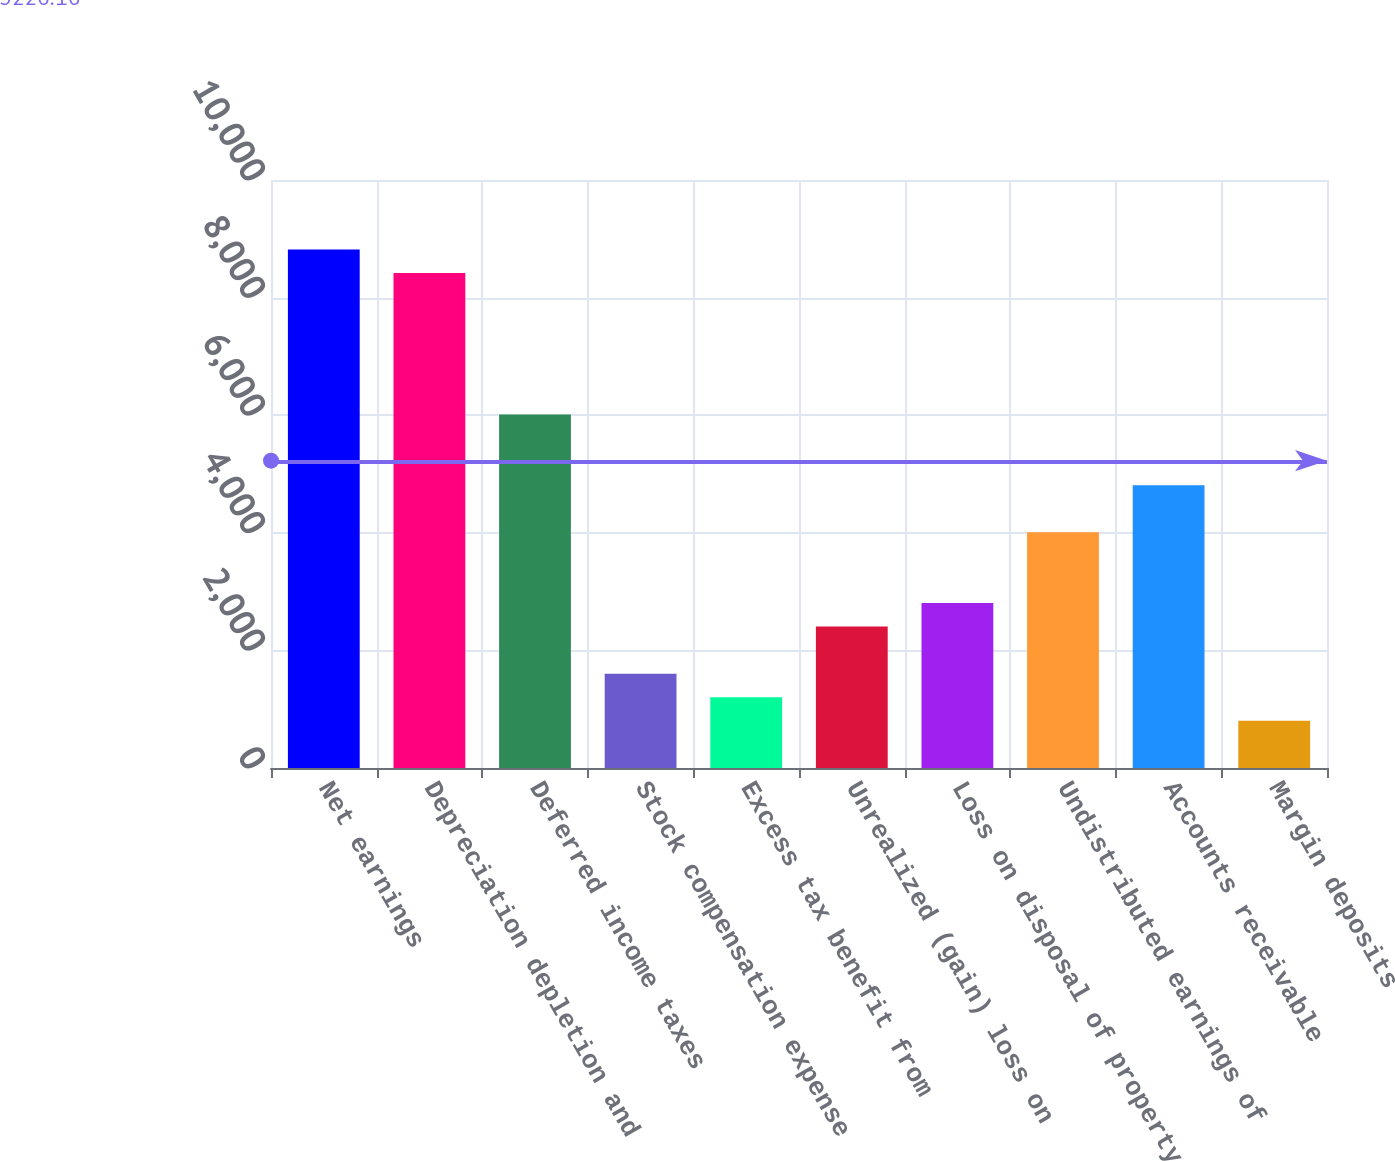Convert chart. <chart><loc_0><loc_0><loc_500><loc_500><bar_chart><fcel>Net earnings<fcel>Depreciation depletion and<fcel>Deferred income taxes<fcel>Stock compensation expense<fcel>Excess tax benefit from<fcel>Unrealized (gain) loss on<fcel>Loss on disposal of property<fcel>Undistributed earnings of<fcel>Accounts receivable<fcel>Margin deposits<nl><fcel>8818.42<fcel>8417.61<fcel>6012.75<fcel>1603.84<fcel>1203.03<fcel>2405.46<fcel>2806.27<fcel>4008.7<fcel>4810.32<fcel>802.22<nl></chart> 